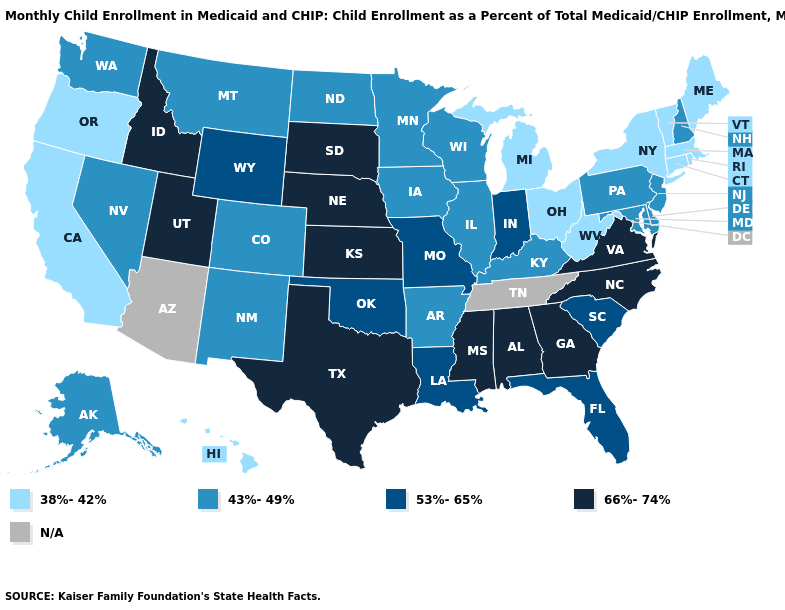Among the states that border Utah , which have the highest value?
Concise answer only. Idaho. Among the states that border North Carolina , which have the highest value?
Keep it brief. Georgia, Virginia. What is the value of Indiana?
Write a very short answer. 53%-65%. Among the states that border Texas , does Arkansas have the lowest value?
Short answer required. Yes. Among the states that border Georgia , does Alabama have the lowest value?
Be succinct. No. What is the lowest value in states that border Nebraska?
Keep it brief. 43%-49%. What is the highest value in the West ?
Answer briefly. 66%-74%. What is the lowest value in the West?
Short answer required. 38%-42%. Name the states that have a value in the range 38%-42%?
Concise answer only. California, Connecticut, Hawaii, Maine, Massachusetts, Michigan, New York, Ohio, Oregon, Rhode Island, Vermont, West Virginia. What is the value of Massachusetts?
Short answer required. 38%-42%. Name the states that have a value in the range 38%-42%?
Write a very short answer. California, Connecticut, Hawaii, Maine, Massachusetts, Michigan, New York, Ohio, Oregon, Rhode Island, Vermont, West Virginia. What is the value of Missouri?
Concise answer only. 53%-65%. What is the highest value in states that border New Jersey?
Write a very short answer. 43%-49%. What is the value of South Carolina?
Answer briefly. 53%-65%. 